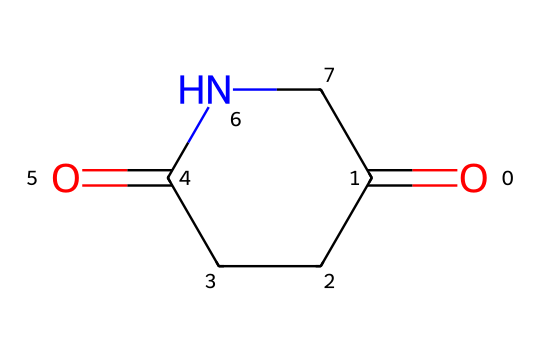What is the number of carbon atoms in glutarimide? The SMILES representation indicates there are three carbon atoms in the aliphatic chain and one in the carbonyl group, totaling four.
Answer: 4 How many nitrogen atoms are in this chemical structure? Analyzing the SMILES shows there is one nitrogen atom in the structure, as denoted by "N".
Answer: 1 What is the total number of oxygen atoms in glutarimide? From the SMILES, there are two carbonyl groups, each containing an oxygen atom, making a total of two oxygen atoms.
Answer: 2 What type of functional group is present in glutarimide? The presence of nitrogen atom adjacent to carbonyl groups indicates the amide functional group, specifically an imide due to two carbonyls interacting with one nitrogen.
Answer: imide How does the structure of glutarimide contribute to its classification as an imide? The two carbonyl groups bonded to the same nitrogen atom define the imide structure, distinguishing it from other amides that only have one carbonyl.
Answer: two carbonyls Is glutarimide a cyclic compound? The description and the SMILES representation reveal that glutarimide features a ring structure, as suggested by the "C1" and "C1" closure notation in SMILES.
Answer: yes 